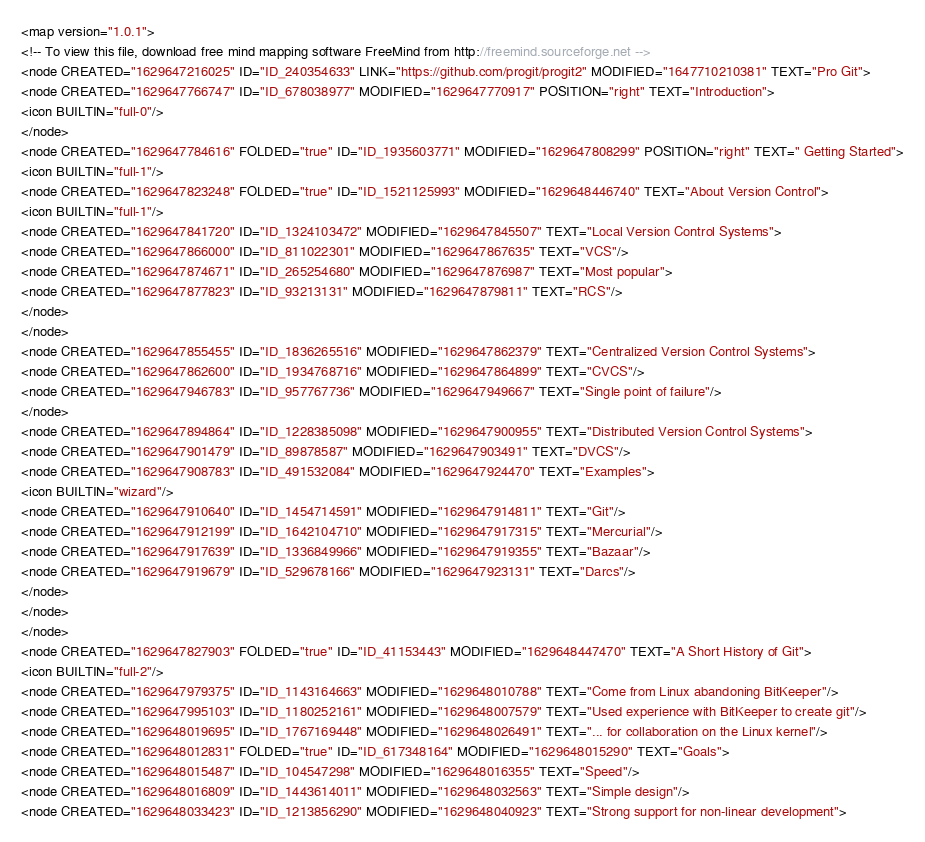Convert code to text. <code><loc_0><loc_0><loc_500><loc_500><_ObjectiveC_><map version="1.0.1">
<!-- To view this file, download free mind mapping software FreeMind from http://freemind.sourceforge.net -->
<node CREATED="1629647216025" ID="ID_240354633" LINK="https://github.com/progit/progit2" MODIFIED="1647710210381" TEXT="Pro Git">
<node CREATED="1629647766747" ID="ID_678038977" MODIFIED="1629647770917" POSITION="right" TEXT="Introduction">
<icon BUILTIN="full-0"/>
</node>
<node CREATED="1629647784616" FOLDED="true" ID="ID_1935603771" MODIFIED="1629647808299" POSITION="right" TEXT=" Getting Started">
<icon BUILTIN="full-1"/>
<node CREATED="1629647823248" FOLDED="true" ID="ID_1521125993" MODIFIED="1629648446740" TEXT="About Version Control">
<icon BUILTIN="full-1"/>
<node CREATED="1629647841720" ID="ID_1324103472" MODIFIED="1629647845507" TEXT="Local Version Control Systems">
<node CREATED="1629647866000" ID="ID_811022301" MODIFIED="1629647867635" TEXT="VCS"/>
<node CREATED="1629647874671" ID="ID_265254680" MODIFIED="1629647876987" TEXT="Most popular">
<node CREATED="1629647877823" ID="ID_93213131" MODIFIED="1629647879811" TEXT="RCS"/>
</node>
</node>
<node CREATED="1629647855455" ID="ID_1836265516" MODIFIED="1629647862379" TEXT="Centralized Version Control Systems">
<node CREATED="1629647862600" ID="ID_1934768716" MODIFIED="1629647864899" TEXT="CVCS"/>
<node CREATED="1629647946783" ID="ID_957767736" MODIFIED="1629647949667" TEXT="Single point of failure"/>
</node>
<node CREATED="1629647894864" ID="ID_1228385098" MODIFIED="1629647900955" TEXT="Distributed Version Control Systems">
<node CREATED="1629647901479" ID="ID_89878587" MODIFIED="1629647903491" TEXT="DVCS"/>
<node CREATED="1629647908783" ID="ID_491532084" MODIFIED="1629647924470" TEXT="Examples">
<icon BUILTIN="wizard"/>
<node CREATED="1629647910640" ID="ID_1454714591" MODIFIED="1629647914811" TEXT="Git"/>
<node CREATED="1629647912199" ID="ID_1642104710" MODIFIED="1629647917315" TEXT="Mercurial"/>
<node CREATED="1629647917639" ID="ID_1336849966" MODIFIED="1629647919355" TEXT="Bazaar"/>
<node CREATED="1629647919679" ID="ID_529678166" MODIFIED="1629647923131" TEXT="Darcs"/>
</node>
</node>
</node>
<node CREATED="1629647827903" FOLDED="true" ID="ID_41153443" MODIFIED="1629648447470" TEXT="A Short History of Git">
<icon BUILTIN="full-2"/>
<node CREATED="1629647979375" ID="ID_1143164663" MODIFIED="1629648010788" TEXT="Come from Linux abandoning BitKeeper"/>
<node CREATED="1629647995103" ID="ID_1180252161" MODIFIED="1629648007579" TEXT="Used experience with BitKeeper to create git"/>
<node CREATED="1629648019695" ID="ID_1767169448" MODIFIED="1629648026491" TEXT="... for collaboration on the Linux kernel"/>
<node CREATED="1629648012831" FOLDED="true" ID="ID_617348164" MODIFIED="1629648015290" TEXT="Goals">
<node CREATED="1629648015487" ID="ID_104547298" MODIFIED="1629648016355" TEXT="Speed"/>
<node CREATED="1629648016809" ID="ID_1443614011" MODIFIED="1629648032563" TEXT="Simple design"/>
<node CREATED="1629648033423" ID="ID_1213856290" MODIFIED="1629648040923" TEXT="Strong support for non-linear development"></code> 